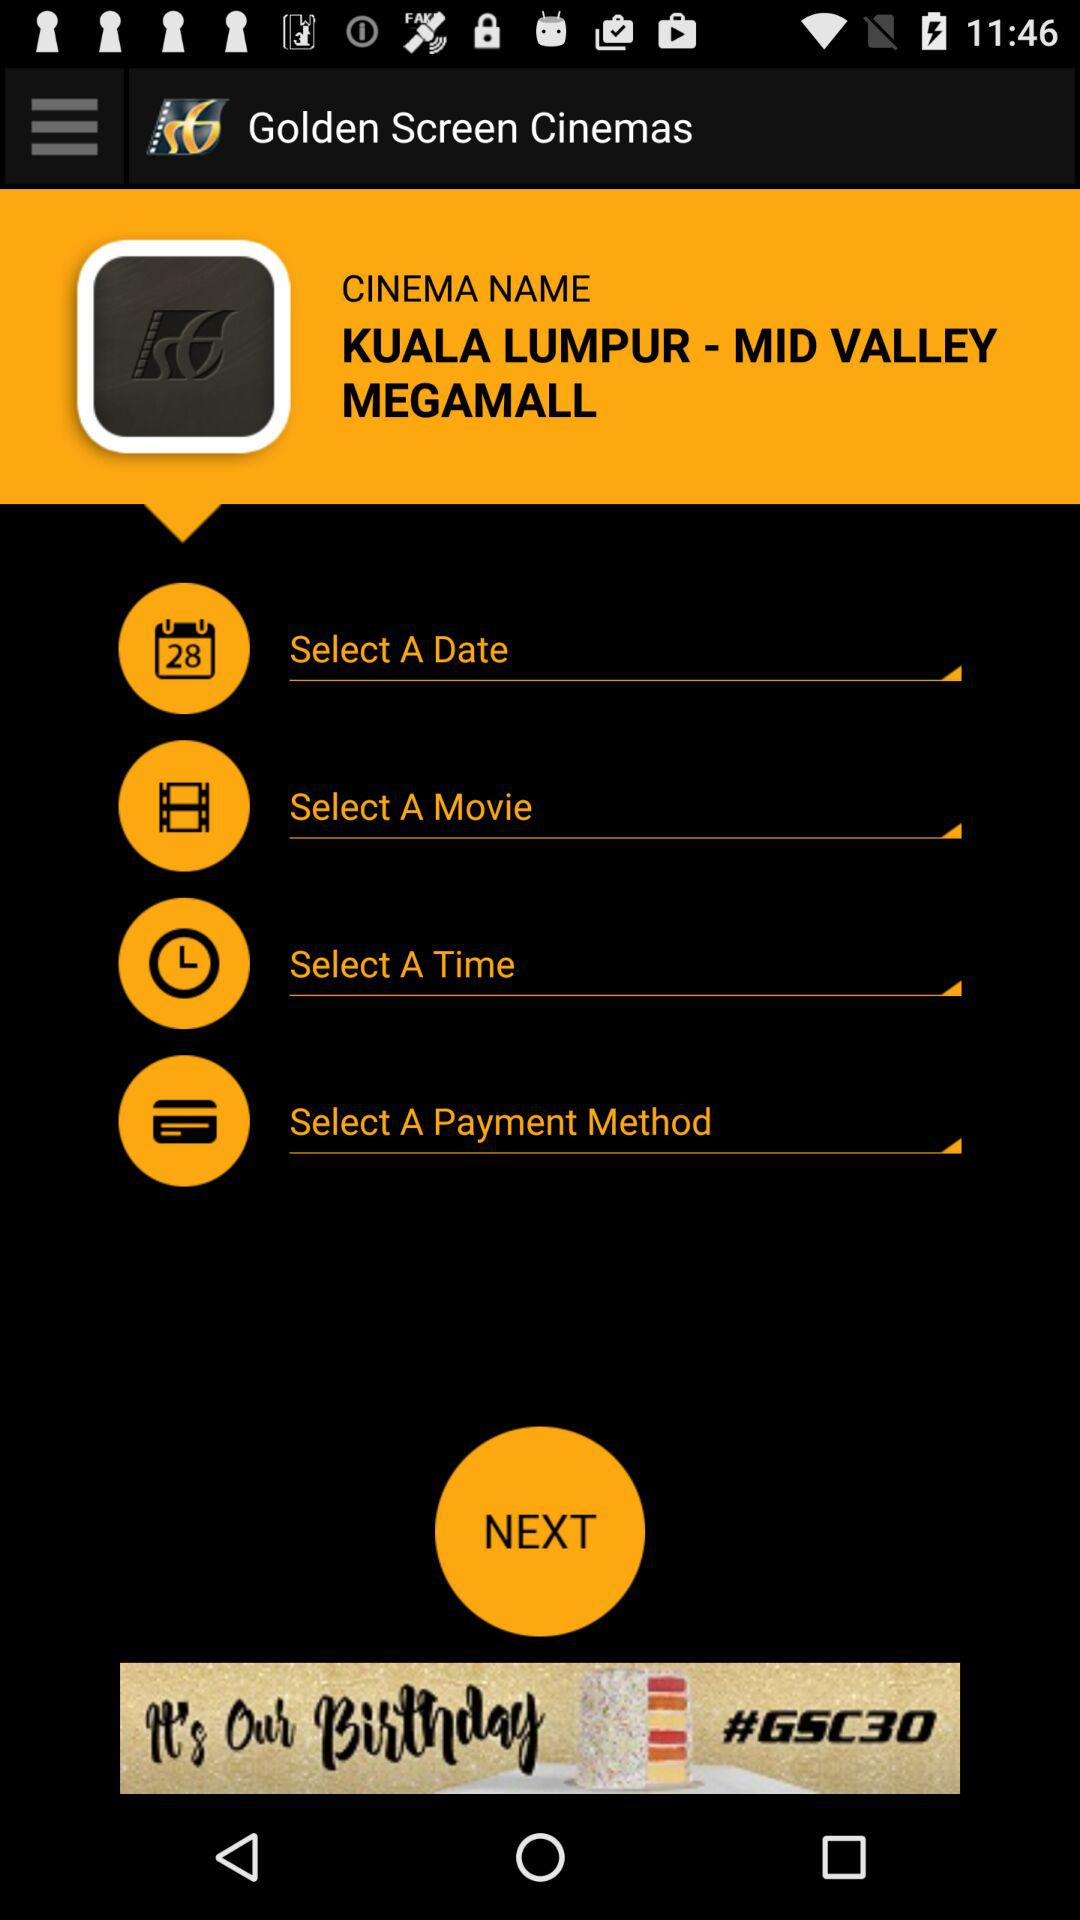What is the name of the cinema? The name of the cinema is "KUALA LUMPUR - MID VALLEY MEGAMALL". 